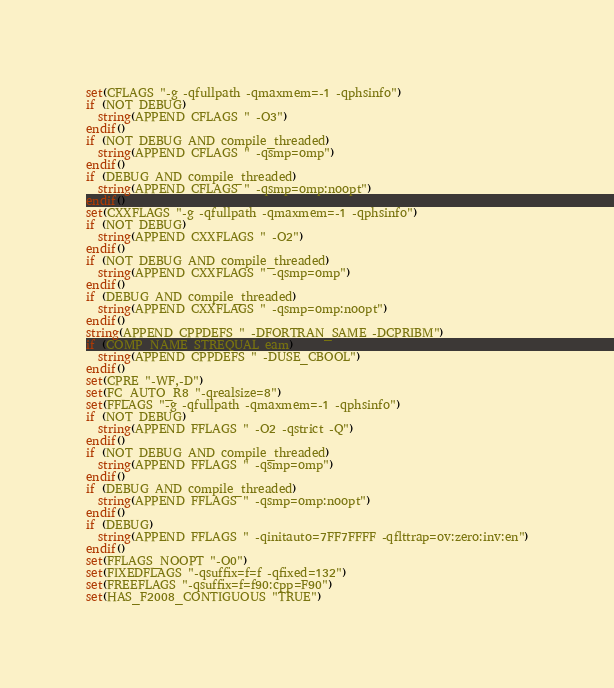Convert code to text. <code><loc_0><loc_0><loc_500><loc_500><_CMake_>set(CFLAGS "-g -qfullpath -qmaxmem=-1 -qphsinfo")
if (NOT DEBUG)
  string(APPEND CFLAGS " -O3")
endif()
if (NOT DEBUG AND compile_threaded)
  string(APPEND CFLAGS " -qsmp=omp")
endif()
if (DEBUG AND compile_threaded)
  string(APPEND CFLAGS " -qsmp=omp:noopt")
endif()
set(CXXFLAGS "-g -qfullpath -qmaxmem=-1 -qphsinfo")
if (NOT DEBUG)
  string(APPEND CXXFLAGS " -O2")
endif()
if (NOT DEBUG AND compile_threaded)
  string(APPEND CXXFLAGS " -qsmp=omp")
endif()
if (DEBUG AND compile_threaded)
  string(APPEND CXXFLAGS " -qsmp=omp:noopt")
endif()
string(APPEND CPPDEFS " -DFORTRAN_SAME -DCPRIBM")
if (COMP_NAME STREQUAL eam)
  string(APPEND CPPDEFS " -DUSE_CBOOL")
endif()
set(CPRE "-WF,-D")
set(FC_AUTO_R8 "-qrealsize=8")
set(FFLAGS "-g -qfullpath -qmaxmem=-1 -qphsinfo")
if (NOT DEBUG)
  string(APPEND FFLAGS " -O2 -qstrict -Q")
endif()
if (NOT DEBUG AND compile_threaded)
  string(APPEND FFLAGS " -qsmp=omp")
endif()
if (DEBUG AND compile_threaded)
  string(APPEND FFLAGS " -qsmp=omp:noopt")
endif()
if (DEBUG)
  string(APPEND FFLAGS " -qinitauto=7FF7FFFF -qflttrap=ov:zero:inv:en")
endif()
set(FFLAGS_NOOPT "-O0")
set(FIXEDFLAGS "-qsuffix=f=f -qfixed=132")
set(FREEFLAGS "-qsuffix=f=f90:cpp=F90")
set(HAS_F2008_CONTIGUOUS "TRUE")
</code> 